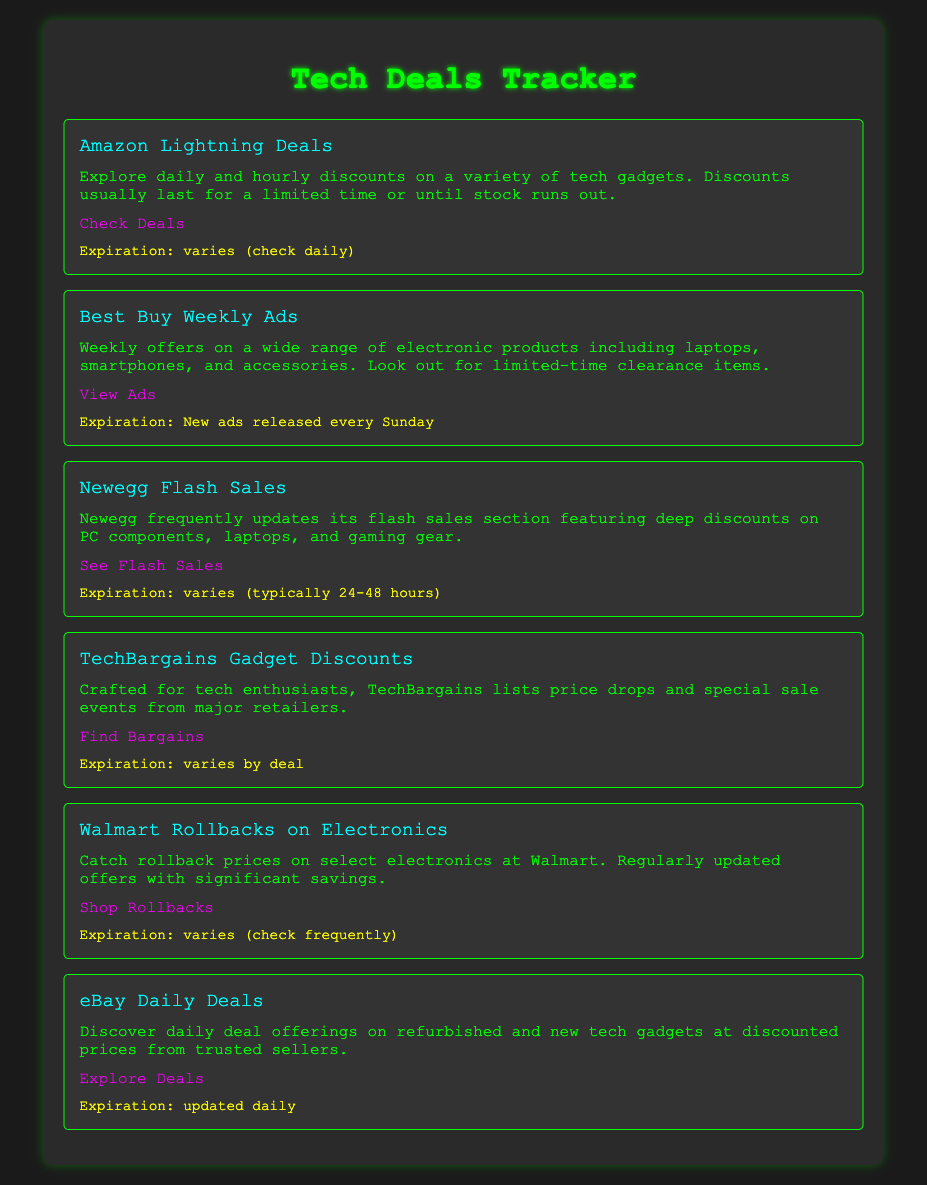What is the title of the document? The title of the document is a main heading that provides a quick overview of its purpose.
Answer: Tech Deals Tracker How often are Amazon Lightning Deals updated? The document mentions that discounts usually last for a limited time or until stock runs out, indicating variability.
Answer: varies (check daily) What type of discounts does Best Buy offer? The document specifies the type of products included in the offers for clarity.
Answer: electronic products When are new Best Buy ads released? The document provides a specific frequency for the release of ads, which helps users know when to check.
Answer: every Sunday What is the typical expiration time for Newegg flash sales? The document outlines how often these sales last, providing a clear timeframe for potential buyers.
Answer: 24-48 hours Which site offers daily deals on refurbished gadgets? The document mentions a specific site that focuses on refurbished and new tech, highlighting its offerings.
Answer: eBay What is a key feature of TechBargains? The document highlights the unique purpose of the site that differentiates it from others.
Answer: price drops How can I view Walmart's rollback offers? The document directs users to a specific page for accessing these deals, guiding them to the right resource.
Answer: Shop Rollbacks What price category does eBay's Daily Deals cover? The document specifically refers to these deals including various gadgets, allowing for targeted inquiries.
Answer: tech gadgets 